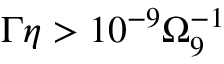<formula> <loc_0><loc_0><loc_500><loc_500>\Gamma \eta > 1 0 ^ { - 9 } \Omega _ { 9 } ^ { - 1 }</formula> 